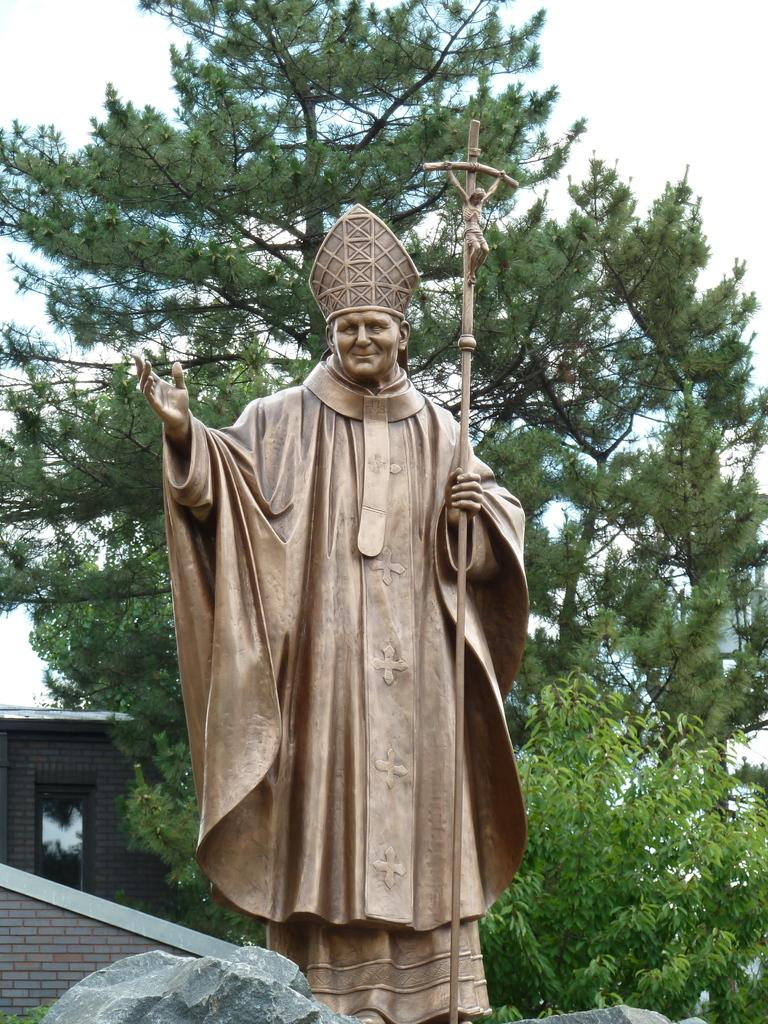What is the main subject in the image? There is a statue in the image. What can be seen in the background of the image? There is a tree in the background of the image. What is located at the bottom of the image? There are rocks at the bottom of the image. Where is the house located in the image? The house is on the left side of the image. What is visible at the top of the image? The sky is visible at the top of the image. How many women are giving birth in the image? There are no women or any indication of birth in the image. 